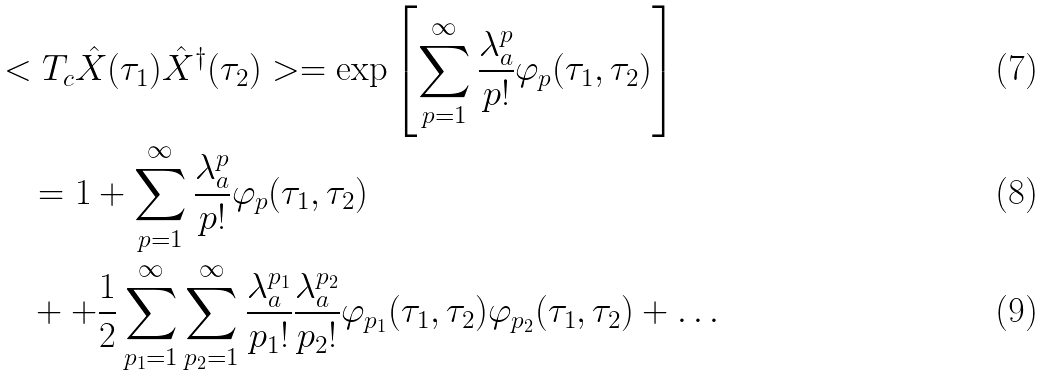<formula> <loc_0><loc_0><loc_500><loc_500>& < T _ { c } \hat { X } ( \tau _ { 1 } ) \hat { X } ^ { \dagger } ( \tau _ { 2 } ) > = \exp \left [ \sum _ { p = 1 } ^ { \infty } \frac { \lambda _ { a } ^ { p } } { p ! } \varphi _ { p } ( \tau _ { 1 } , \tau _ { 2 } ) \right ] \\ & \quad = 1 + \sum _ { p = 1 } ^ { \infty } \frac { \lambda _ { a } ^ { p } } { p ! } \varphi _ { p } ( \tau _ { 1 } , \tau _ { 2 } ) \\ & \quad + + \frac { 1 } { 2 } \sum _ { p _ { 1 } = 1 } ^ { \infty } \sum _ { p _ { 2 } = 1 } ^ { \infty } \frac { \lambda _ { a } ^ { p _ { 1 } } } { p _ { 1 } ! } \frac { \lambda _ { a } ^ { p _ { 2 } } } { p _ { 2 } ! } \varphi _ { p _ { 1 } } ( \tau _ { 1 } , \tau _ { 2 } ) \varphi _ { p _ { 2 } } ( \tau _ { 1 } , \tau _ { 2 } ) + \dots</formula> 